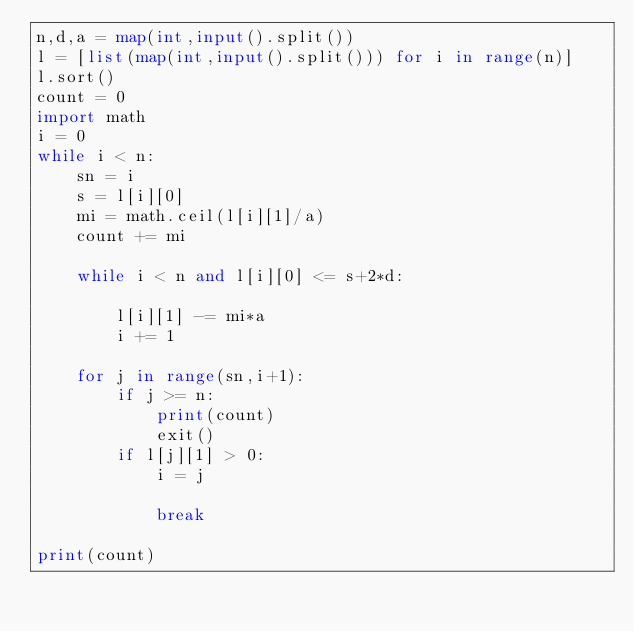<code> <loc_0><loc_0><loc_500><loc_500><_Python_>n,d,a = map(int,input().split())
l = [list(map(int,input().split())) for i in range(n)]
l.sort()
count = 0
import math
i = 0
while i < n:
    sn = i
    s = l[i][0]
    mi = math.ceil(l[i][1]/a)
    count += mi
    
    while i < n and l[i][0] <= s+2*d:
        
        l[i][1] -= mi*a
        i += 1
        
    for j in range(sn,i+1):
        if j >= n:
            print(count)
            exit()
        if l[j][1] > 0:
            i = j
            
            break

print(count)   
</code> 